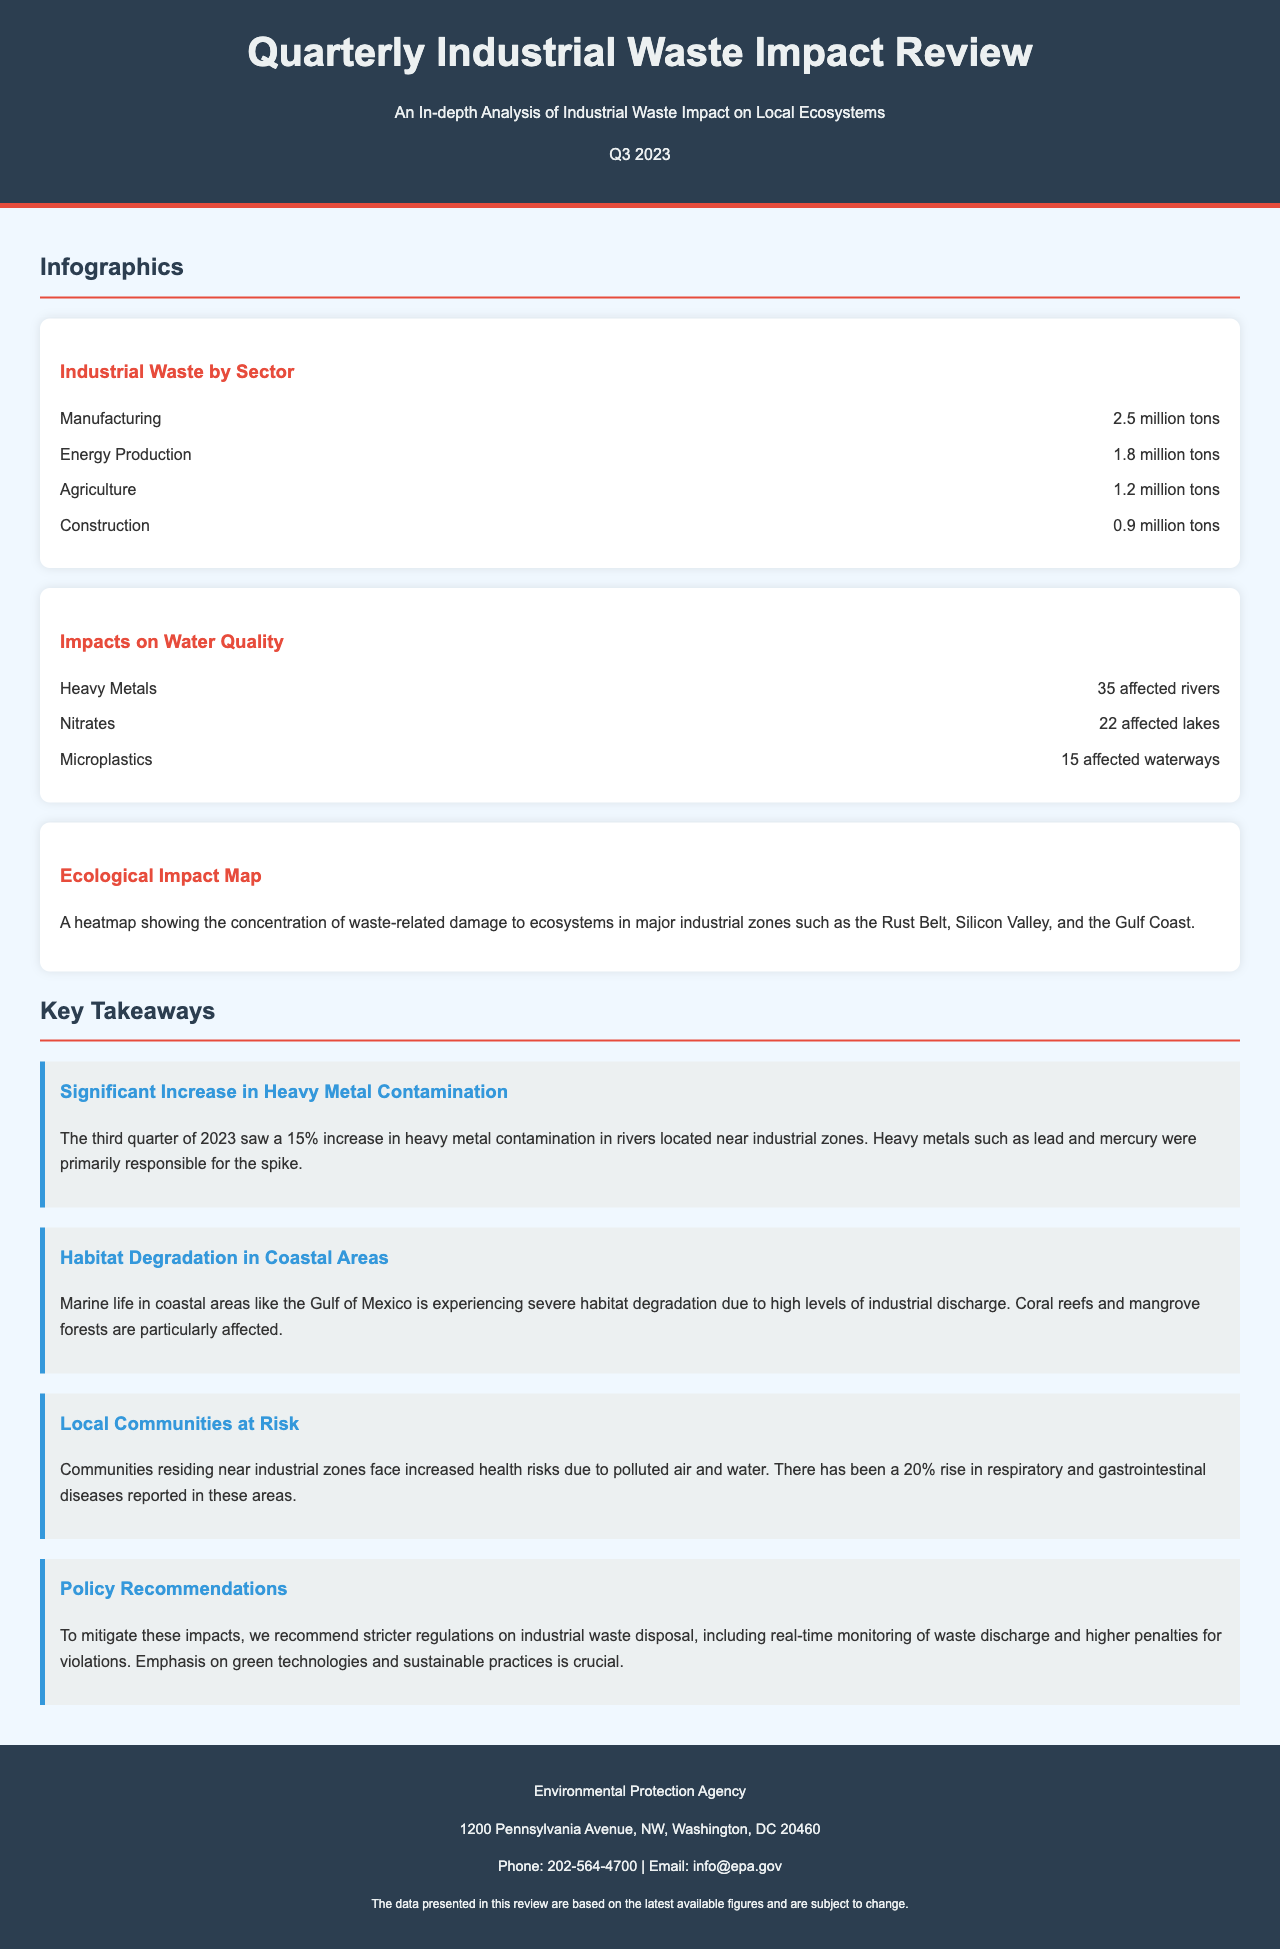what is the title of the document? The title of the document is prominently displayed at the top and indicates the overall subject.
Answer: Quarterly Industrial Waste Impact Review what quarter and year does the review cover? The document includes the quarter and year, specifically indicated in the header.
Answer: Q3 2023 how many tons of industrial waste does the manufacturing sector produce? The document lists the industrial waste by sector with specific figures included.
Answer: 2.5 million tons what percentage increase in heavy metal contamination was reported? The key takeaway section details significant changes in environmental data, including specific percentages.
Answer: 15% how many affected rivers reported heavy metals? The infographic on water quality impacts highlights the number of rivers affected by heavy metals.
Answer: 35 affected rivers which sector produced the least amount of waste? The data points in the infographic on industrial waste by sector allow for comparison of waste amounts.
Answer: Construction what are the health risks faced by local communities? The document indicates health risks associated with industrial zones, which are detailed in the key takeaway section.
Answer: Respiratory and gastrointestinal diseases what is a recommended policy action mentioned in the review? The key takeaways section provides recommendations for addressing the issues raised in the review.
Answer: Stricter regulations on industrial waste disposal how many affected lakes reported nitrates? The infographic includes specific numbers related to the impact of nitrates on local water bodies.
Answer: 22 affected lakes 